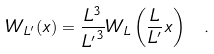<formula> <loc_0><loc_0><loc_500><loc_500>W _ { L ^ { \prime } } ( x ) = \frac { L ^ { 3 } } { { L ^ { \prime } } ^ { 3 } } W _ { L } \left ( \frac { L } { L ^ { \prime } } x \right ) \ .</formula> 